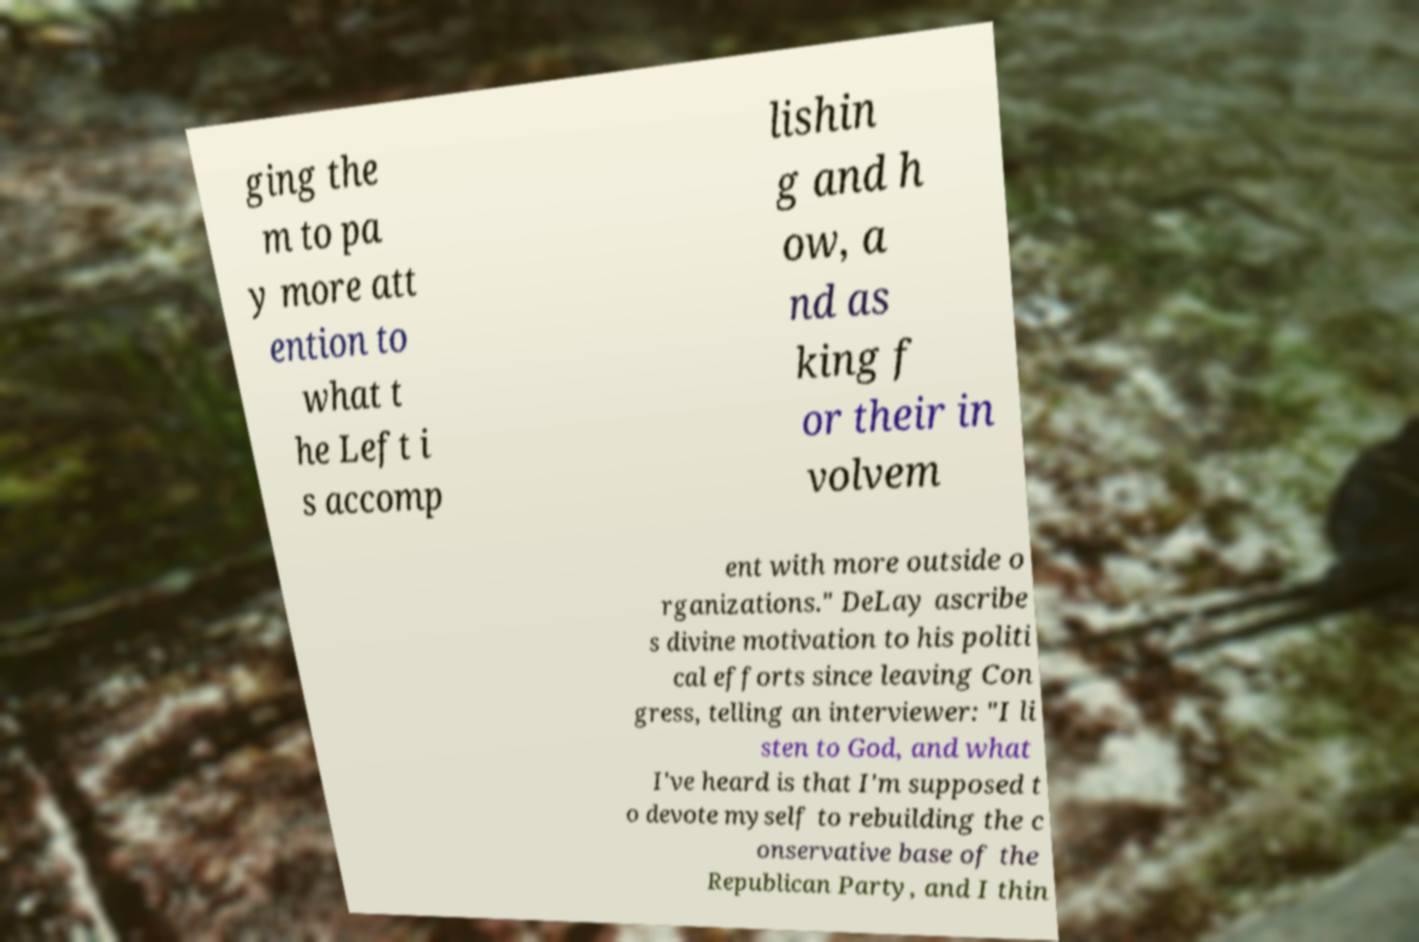I need the written content from this picture converted into text. Can you do that? ging the m to pa y more att ention to what t he Left i s accomp lishin g and h ow, a nd as king f or their in volvem ent with more outside o rganizations." DeLay ascribe s divine motivation to his politi cal efforts since leaving Con gress, telling an interviewer: "I li sten to God, and what I've heard is that I'm supposed t o devote myself to rebuilding the c onservative base of the Republican Party, and I thin 